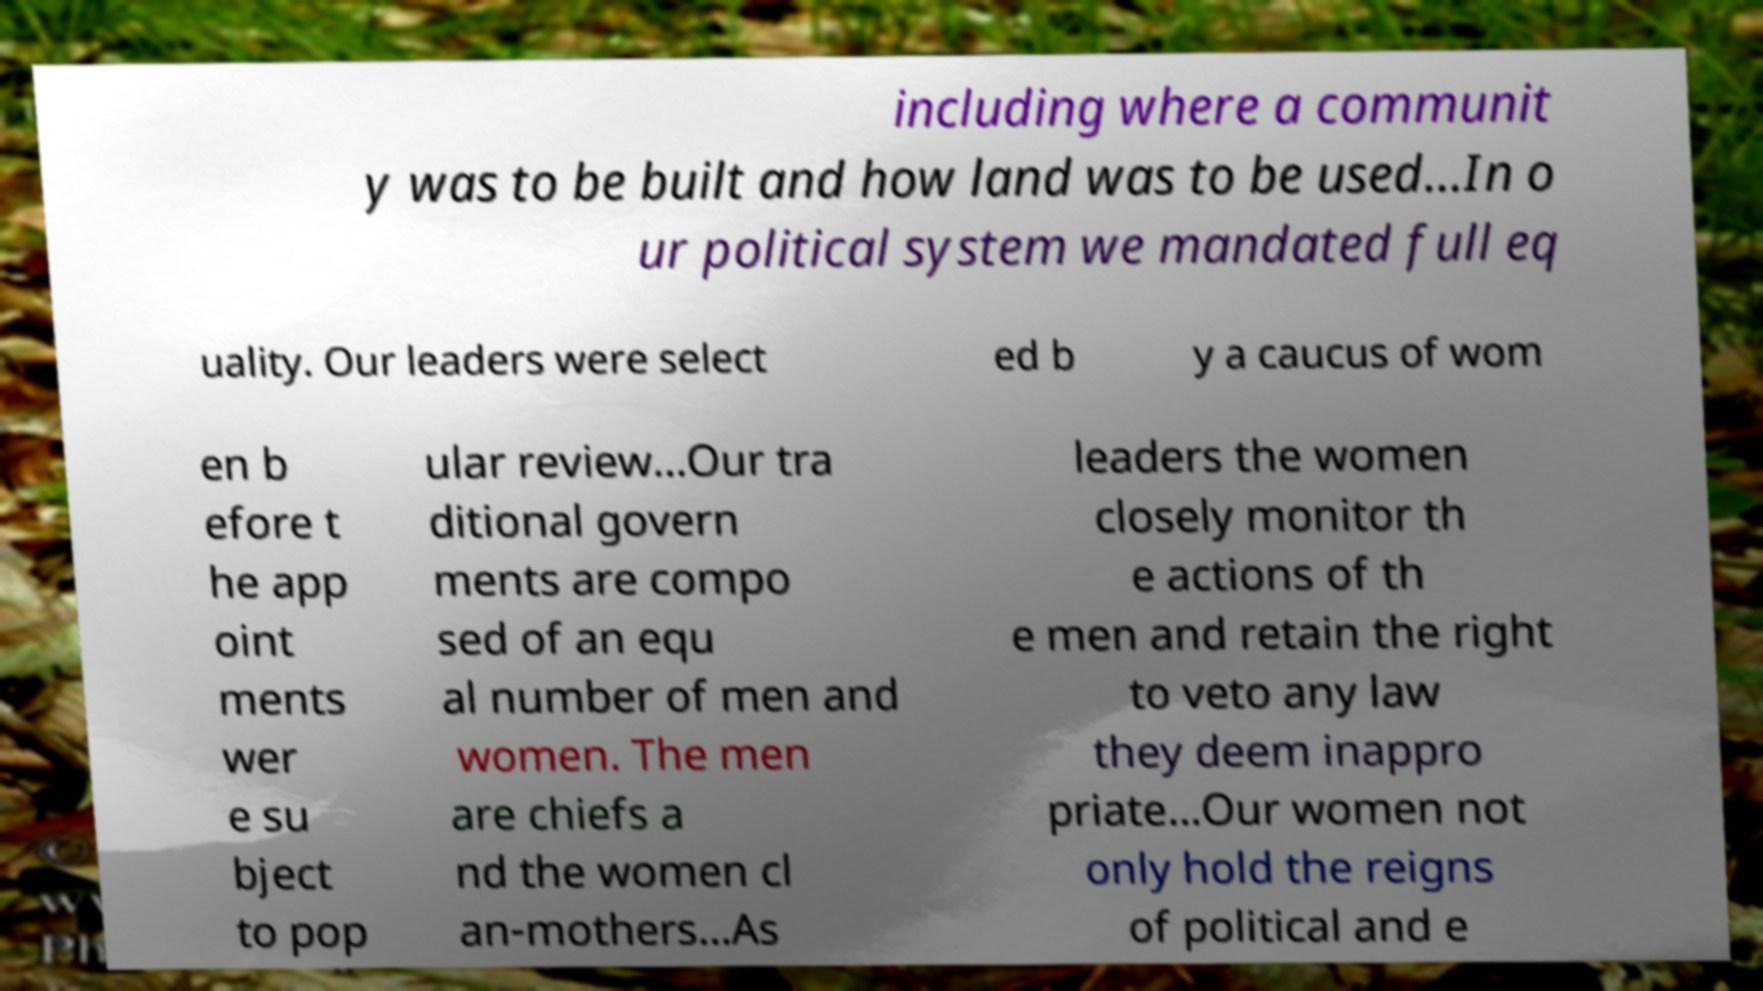I need the written content from this picture converted into text. Can you do that? including where a communit y was to be built and how land was to be used...In o ur political system we mandated full eq uality. Our leaders were select ed b y a caucus of wom en b efore t he app oint ments wer e su bject to pop ular review...Our tra ditional govern ments are compo sed of an equ al number of men and women. The men are chiefs a nd the women cl an-mothers...As leaders the women closely monitor th e actions of th e men and retain the right to veto any law they deem inappro priate...Our women not only hold the reigns of political and e 